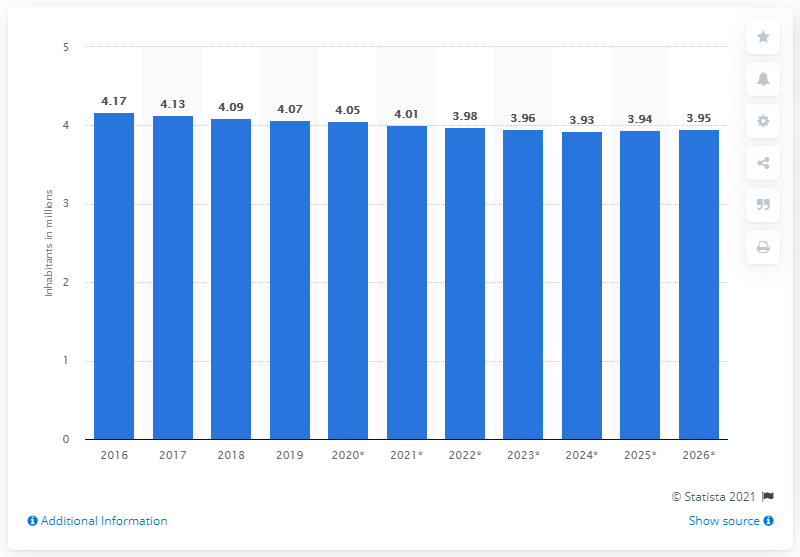Specify some key components in this picture. In 2019, the population of Croatia was approximately 4.05 million. 